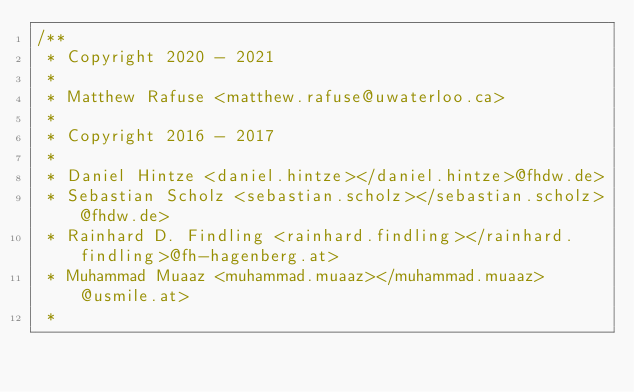<code> <loc_0><loc_0><loc_500><loc_500><_Kotlin_>/**
 * Copyright 2020 - 2021
 *
 * Matthew Rafuse <matthew.rafuse@uwaterloo.ca>
 *
 * Copyright 2016 - 2017
 *
 * Daniel Hintze <daniel.hintze></daniel.hintze>@fhdw.de>
 * Sebastian Scholz <sebastian.scholz></sebastian.scholz>@fhdw.de>
 * Rainhard D. Findling <rainhard.findling></rainhard.findling>@fh-hagenberg.at>
 * Muhammad Muaaz <muhammad.muaaz></muhammad.muaaz>@usmile.at>
 *</code> 